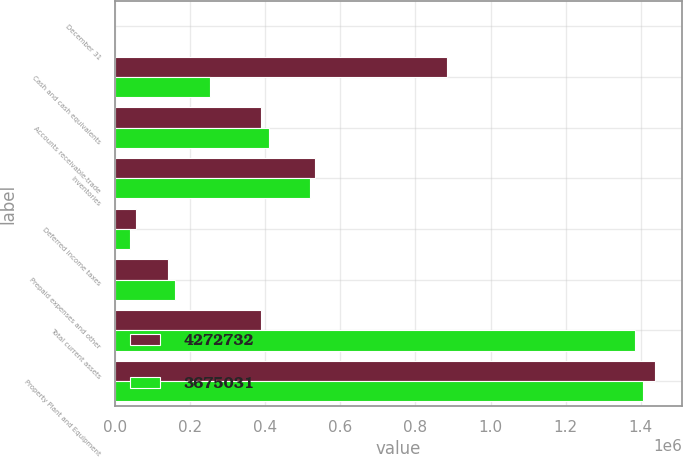<chart> <loc_0><loc_0><loc_500><loc_500><stacked_bar_chart><ecel><fcel>December 31<fcel>Cash and cash equivalents<fcel>Accounts receivable-trade<fcel>Inventories<fcel>Deferred income taxes<fcel>Prepaid expenses and other<fcel>Total current assets<fcel>Property Plant and Equipment<nl><fcel>4.27273e+06<fcel>2010<fcel>884642<fcel>390061<fcel>533622<fcel>55760<fcel>141132<fcel>390061<fcel>1.4377e+06<nl><fcel>3.67503e+06<fcel>2009<fcel>253605<fcel>410390<fcel>519712<fcel>39868<fcel>161859<fcel>1.38543e+06<fcel>1.40477e+06<nl></chart> 